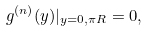<formula> <loc_0><loc_0><loc_500><loc_500>g ^ { ( n ) } ( y ) | _ { y = 0 , \pi R } = 0 ,</formula> 